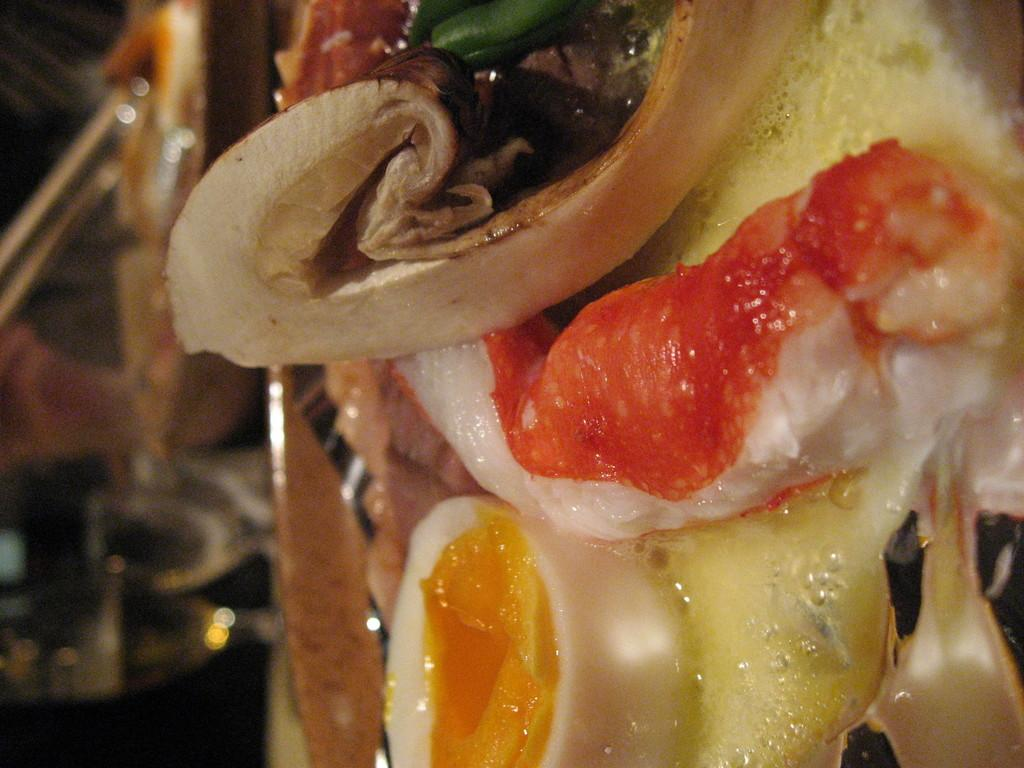What types of objects can be seen in the image? There are food items, glasses, and chopsticks in the image. Can you describe the food items in the image? Unfortunately, the provided facts do not specify the type of food items in the image. What is the purpose of the glasses in the image? The purpose of the glasses in the image is not clear from the provided facts. Are there any objects in the image that are not clearly visible? Yes, there are blurred objects in the image. What type of plant is growing in the bread in the image? There is no bread or plant present in the image. 